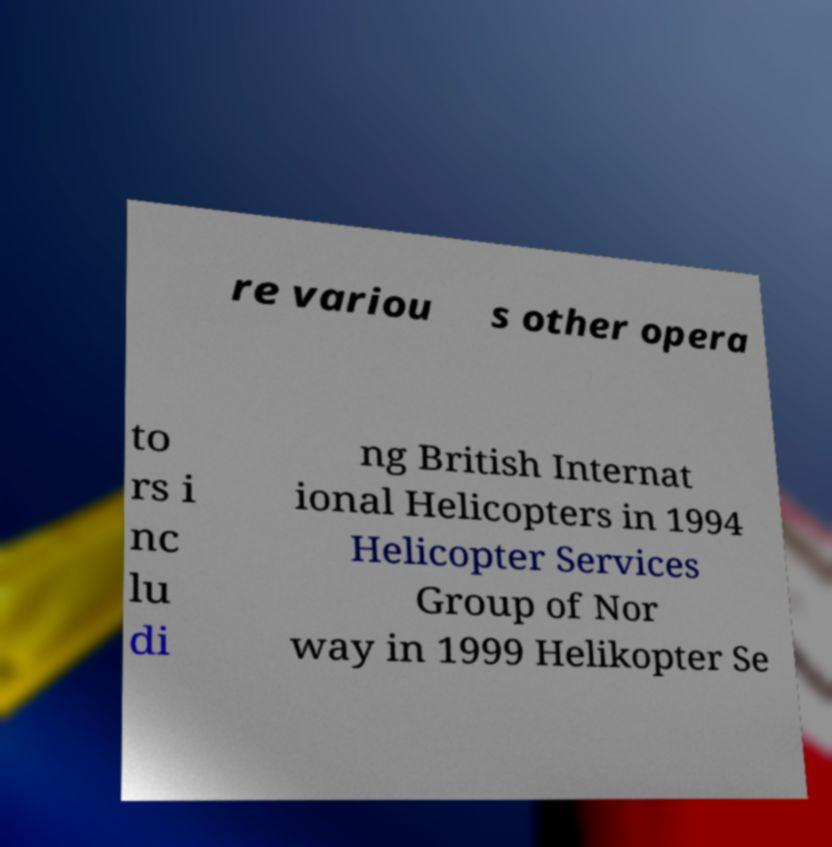What messages or text are displayed in this image? I need them in a readable, typed format. re variou s other opera to rs i nc lu di ng British Internat ional Helicopters in 1994 Helicopter Services Group of Nor way in 1999 Helikopter Se 